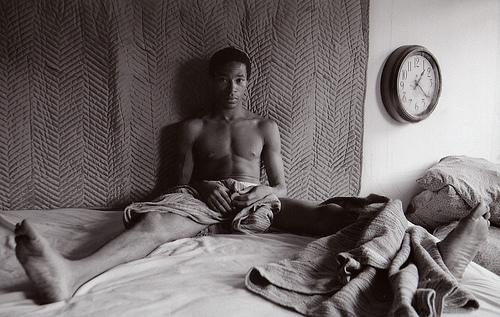Question: what is the man doing?
Choices:
A. Sitting up.
B. Standing.
C. Laying down.
D. Jumping.
Answer with the letter. Answer: A Question: how many people are in the room?
Choices:
A. Two.
B. Three.
C. Four.
D. One.
Answer with the letter. Answer: D 